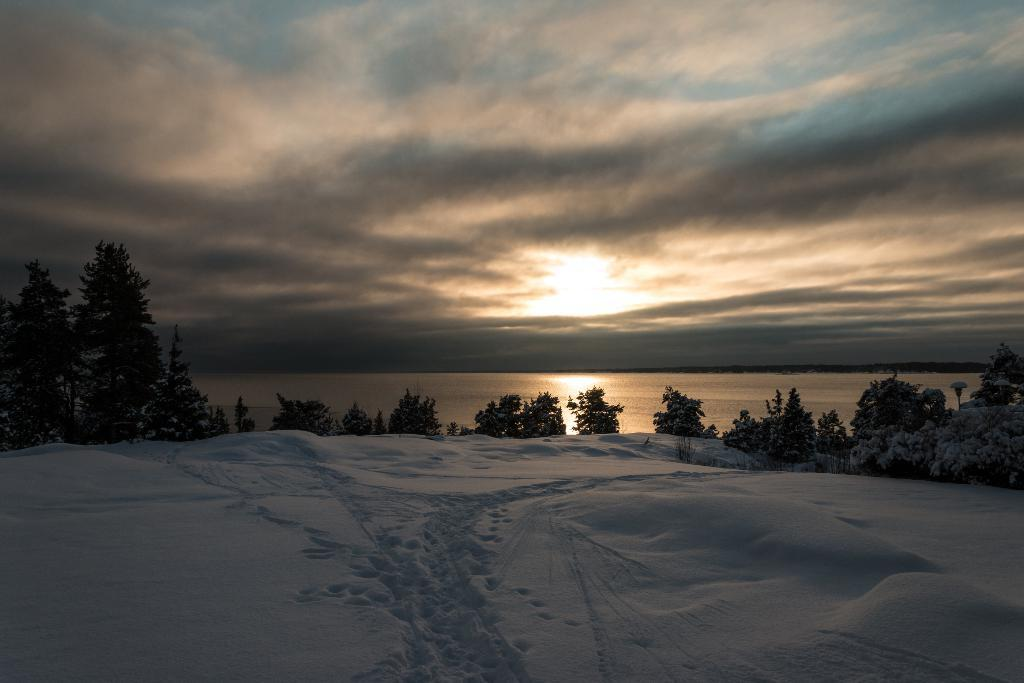What is the predominant weather condition in the image? There is snow in the image, indicating a cold and wintry condition. What type of natural vegetation can be seen in the image? There are trees in the image. What can be seen in the distance in the image? There is water visible in the background of the image. What is visible in the sky in the image? Clouds are present in the background of the image. How does the snow comfort the trees in the image? The snow does not comfort the trees in the image; it is simply a weather condition that affects the environment. 